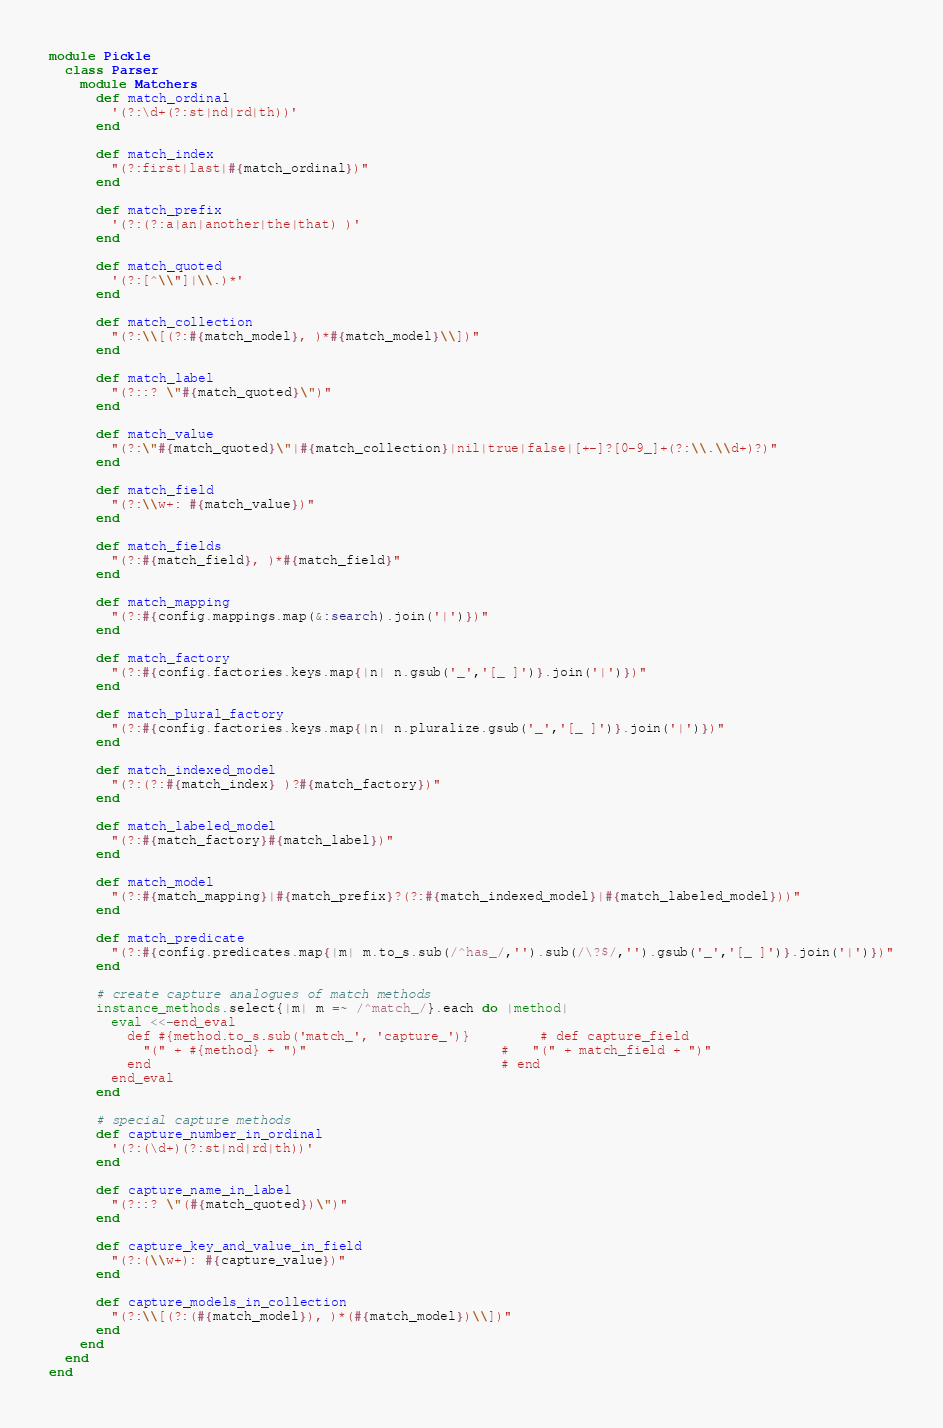<code> <loc_0><loc_0><loc_500><loc_500><_Ruby_>module Pickle
  class Parser
    module Matchers
      def match_ordinal
        '(?:\d+(?:st|nd|rd|th))'
      end

      def match_index
        "(?:first|last|#{match_ordinal})"
      end

      def match_prefix
        '(?:(?:a|an|another|the|that) )'
      end

      def match_quoted
        '(?:[^\\"]|\\.)*'
      end

      def match_collection
        "(?:\\[(?:#{match_model}, )*#{match_model}\\])"
      end

      def match_label
        "(?::? \"#{match_quoted}\")"
      end

      def match_value
        "(?:\"#{match_quoted}\"|#{match_collection}|nil|true|false|[+-]?[0-9_]+(?:\\.\\d+)?)"
      end

      def match_field
        "(?:\\w+: #{match_value})"
      end

      def match_fields
        "(?:#{match_field}, )*#{match_field}"
      end

      def match_mapping
        "(?:#{config.mappings.map(&:search).join('|')})"
      end

      def match_factory
        "(?:#{config.factories.keys.map{|n| n.gsub('_','[_ ]')}.join('|')})"
      end

      def match_plural_factory
        "(?:#{config.factories.keys.map{|n| n.pluralize.gsub('_','[_ ]')}.join('|')})"
      end

      def match_indexed_model
        "(?:(?:#{match_index} )?#{match_factory})"
      end

      def match_labeled_model
        "(?:#{match_factory}#{match_label})"
      end

      def match_model
        "(?:#{match_mapping}|#{match_prefix}?(?:#{match_indexed_model}|#{match_labeled_model}))"
      end

      def match_predicate
        "(?:#{config.predicates.map{|m| m.to_s.sub(/^has_/,'').sub(/\?$/,'').gsub('_','[_ ]')}.join('|')})"
      end

      # create capture analogues of match methods
      instance_methods.select{|m| m =~ /^match_/}.each do |method|
        eval <<-end_eval
          def #{method.to_s.sub('match_', 'capture_')}         # def capture_field
            "(" + #{method} + ")"                         #   "(" + match_field + ")"
          end                                             # end
        end_eval
      end

      # special capture methods
      def capture_number_in_ordinal
        '(?:(\d+)(?:st|nd|rd|th))'
      end

      def capture_name_in_label
        "(?::? \"(#{match_quoted})\")"
      end

      def capture_key_and_value_in_field
        "(?:(\\w+): #{capture_value})"
      end

      def capture_models_in_collection
        "(?:\\[(?:(#{match_model}), )*(#{match_model})\\])"
      end
    end
  end
end
</code> 